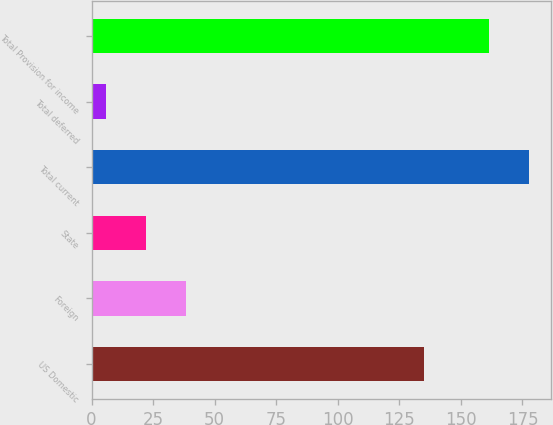<chart> <loc_0><loc_0><loc_500><loc_500><bar_chart><fcel>US Domestic<fcel>Foreign<fcel>State<fcel>Total current<fcel>Total deferred<fcel>Total Provision for income<nl><fcel>134.9<fcel>38.18<fcel>22.04<fcel>177.54<fcel>5.9<fcel>161.4<nl></chart> 